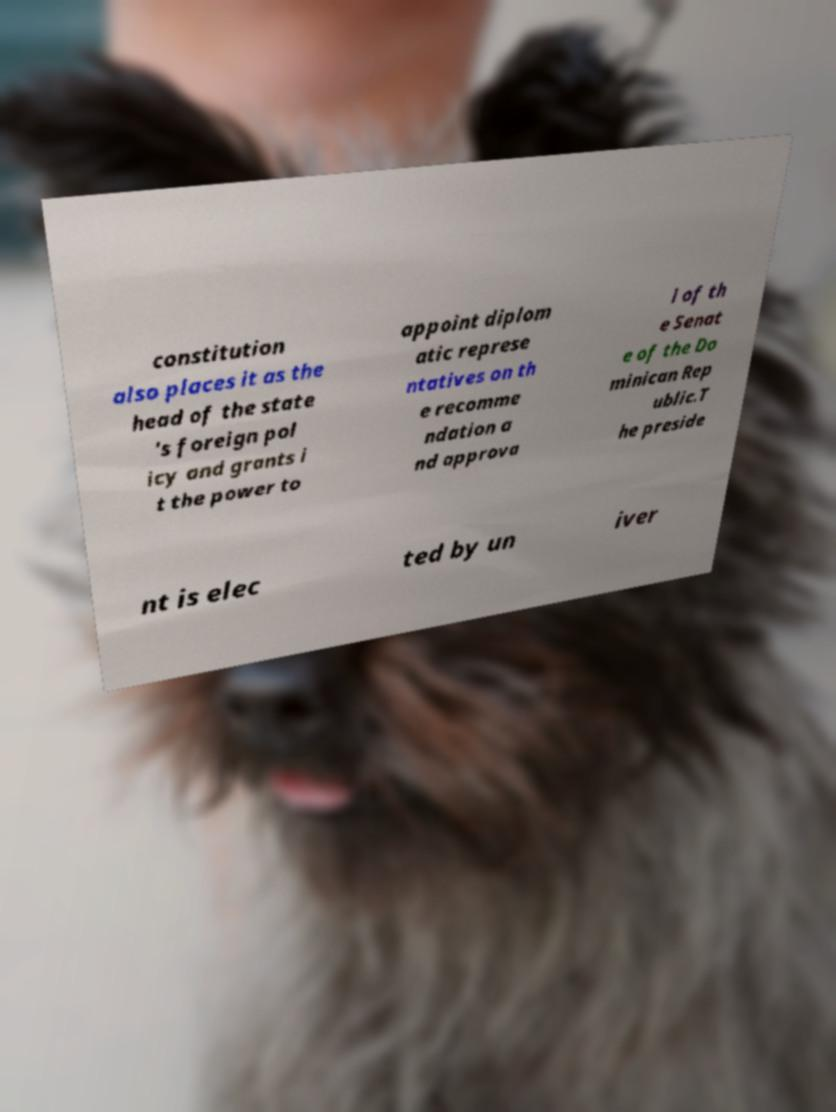Can you accurately transcribe the text from the provided image for me? constitution also places it as the head of the state 's foreign pol icy and grants i t the power to appoint diplom atic represe ntatives on th e recomme ndation a nd approva l of th e Senat e of the Do minican Rep ublic.T he preside nt is elec ted by un iver 